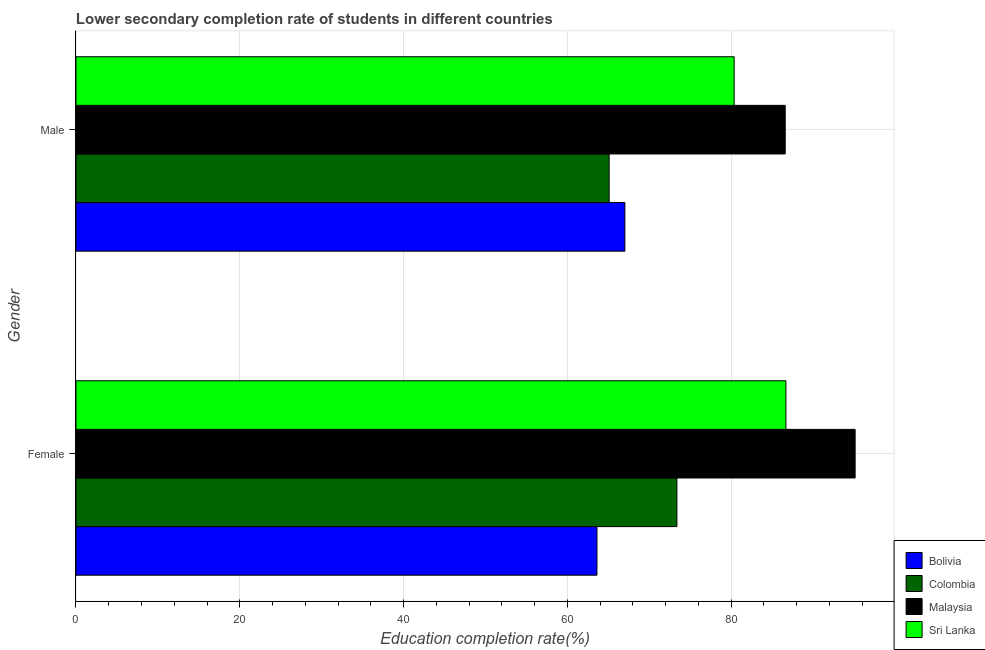How many different coloured bars are there?
Keep it short and to the point. 4. How many bars are there on the 1st tick from the top?
Keep it short and to the point. 4. How many bars are there on the 1st tick from the bottom?
Your answer should be compact. 4. What is the education completion rate of male students in Malaysia?
Offer a terse response. 86.61. Across all countries, what is the maximum education completion rate of female students?
Keep it short and to the point. 95.14. Across all countries, what is the minimum education completion rate of male students?
Your response must be concise. 65.11. In which country was the education completion rate of female students maximum?
Keep it short and to the point. Malaysia. In which country was the education completion rate of female students minimum?
Provide a short and direct response. Bolivia. What is the total education completion rate of female students in the graph?
Make the answer very short. 318.83. What is the difference between the education completion rate of female students in Sri Lanka and that in Bolivia?
Offer a very short reply. 23.07. What is the difference between the education completion rate of female students in Sri Lanka and the education completion rate of male students in Colombia?
Give a very brief answer. 21.58. What is the average education completion rate of male students per country?
Ensure brevity in your answer.  74.78. What is the difference between the education completion rate of male students and education completion rate of female students in Colombia?
Keep it short and to the point. -8.27. In how many countries, is the education completion rate of male students greater than 40 %?
Offer a terse response. 4. What is the ratio of the education completion rate of male students in Sri Lanka to that in Malaysia?
Your response must be concise. 0.93. In how many countries, is the education completion rate of female students greater than the average education completion rate of female students taken over all countries?
Your answer should be very brief. 2. What does the 2nd bar from the top in Male represents?
Provide a succinct answer. Malaysia. What does the 4th bar from the bottom in Female represents?
Your answer should be very brief. Sri Lanka. How many bars are there?
Give a very brief answer. 8. What is the difference between two consecutive major ticks on the X-axis?
Provide a succinct answer. 20. Does the graph contain any zero values?
Provide a succinct answer. No. Does the graph contain grids?
Your response must be concise. Yes. Where does the legend appear in the graph?
Keep it short and to the point. Bottom right. How many legend labels are there?
Your answer should be compact. 4. How are the legend labels stacked?
Give a very brief answer. Vertical. What is the title of the graph?
Your answer should be compact. Lower secondary completion rate of students in different countries. What is the label or title of the X-axis?
Keep it short and to the point. Education completion rate(%). What is the label or title of the Y-axis?
Offer a very short reply. Gender. What is the Education completion rate(%) of Bolivia in Female?
Your answer should be very brief. 63.62. What is the Education completion rate(%) of Colombia in Female?
Your response must be concise. 73.38. What is the Education completion rate(%) of Malaysia in Female?
Ensure brevity in your answer.  95.14. What is the Education completion rate(%) in Sri Lanka in Female?
Offer a terse response. 86.69. What is the Education completion rate(%) of Bolivia in Male?
Offer a very short reply. 67.03. What is the Education completion rate(%) in Colombia in Male?
Give a very brief answer. 65.11. What is the Education completion rate(%) of Malaysia in Male?
Keep it short and to the point. 86.61. What is the Education completion rate(%) of Sri Lanka in Male?
Offer a very short reply. 80.37. Across all Gender, what is the maximum Education completion rate(%) of Bolivia?
Your response must be concise. 67.03. Across all Gender, what is the maximum Education completion rate(%) in Colombia?
Keep it short and to the point. 73.38. Across all Gender, what is the maximum Education completion rate(%) of Malaysia?
Keep it short and to the point. 95.14. Across all Gender, what is the maximum Education completion rate(%) in Sri Lanka?
Provide a succinct answer. 86.69. Across all Gender, what is the minimum Education completion rate(%) in Bolivia?
Offer a very short reply. 63.62. Across all Gender, what is the minimum Education completion rate(%) in Colombia?
Offer a terse response. 65.11. Across all Gender, what is the minimum Education completion rate(%) in Malaysia?
Ensure brevity in your answer.  86.61. Across all Gender, what is the minimum Education completion rate(%) of Sri Lanka?
Make the answer very short. 80.37. What is the total Education completion rate(%) in Bolivia in the graph?
Provide a short and direct response. 130.64. What is the total Education completion rate(%) of Colombia in the graph?
Make the answer very short. 138.48. What is the total Education completion rate(%) in Malaysia in the graph?
Offer a very short reply. 181.75. What is the total Education completion rate(%) in Sri Lanka in the graph?
Provide a succinct answer. 167.06. What is the difference between the Education completion rate(%) of Bolivia in Female and that in Male?
Ensure brevity in your answer.  -3.41. What is the difference between the Education completion rate(%) of Colombia in Female and that in Male?
Make the answer very short. 8.27. What is the difference between the Education completion rate(%) in Malaysia in Female and that in Male?
Your response must be concise. 8.53. What is the difference between the Education completion rate(%) of Sri Lanka in Female and that in Male?
Keep it short and to the point. 6.32. What is the difference between the Education completion rate(%) in Bolivia in Female and the Education completion rate(%) in Colombia in Male?
Your answer should be very brief. -1.49. What is the difference between the Education completion rate(%) in Bolivia in Female and the Education completion rate(%) in Malaysia in Male?
Provide a succinct answer. -22.99. What is the difference between the Education completion rate(%) of Bolivia in Female and the Education completion rate(%) of Sri Lanka in Male?
Offer a very short reply. -16.75. What is the difference between the Education completion rate(%) of Colombia in Female and the Education completion rate(%) of Malaysia in Male?
Your response must be concise. -13.23. What is the difference between the Education completion rate(%) in Colombia in Female and the Education completion rate(%) in Sri Lanka in Male?
Give a very brief answer. -6.99. What is the difference between the Education completion rate(%) of Malaysia in Female and the Education completion rate(%) of Sri Lanka in Male?
Offer a terse response. 14.77. What is the average Education completion rate(%) of Bolivia per Gender?
Ensure brevity in your answer.  65.32. What is the average Education completion rate(%) in Colombia per Gender?
Provide a short and direct response. 69.24. What is the average Education completion rate(%) in Malaysia per Gender?
Keep it short and to the point. 90.87. What is the average Education completion rate(%) in Sri Lanka per Gender?
Your answer should be compact. 83.53. What is the difference between the Education completion rate(%) in Bolivia and Education completion rate(%) in Colombia in Female?
Give a very brief answer. -9.76. What is the difference between the Education completion rate(%) in Bolivia and Education completion rate(%) in Malaysia in Female?
Ensure brevity in your answer.  -31.52. What is the difference between the Education completion rate(%) in Bolivia and Education completion rate(%) in Sri Lanka in Female?
Give a very brief answer. -23.07. What is the difference between the Education completion rate(%) in Colombia and Education completion rate(%) in Malaysia in Female?
Your response must be concise. -21.76. What is the difference between the Education completion rate(%) of Colombia and Education completion rate(%) of Sri Lanka in Female?
Provide a short and direct response. -13.31. What is the difference between the Education completion rate(%) in Malaysia and Education completion rate(%) in Sri Lanka in Female?
Offer a very short reply. 8.45. What is the difference between the Education completion rate(%) in Bolivia and Education completion rate(%) in Colombia in Male?
Your response must be concise. 1.92. What is the difference between the Education completion rate(%) of Bolivia and Education completion rate(%) of Malaysia in Male?
Your answer should be very brief. -19.58. What is the difference between the Education completion rate(%) in Bolivia and Education completion rate(%) in Sri Lanka in Male?
Offer a very short reply. -13.34. What is the difference between the Education completion rate(%) in Colombia and Education completion rate(%) in Malaysia in Male?
Your response must be concise. -21.5. What is the difference between the Education completion rate(%) of Colombia and Education completion rate(%) of Sri Lanka in Male?
Offer a very short reply. -15.26. What is the difference between the Education completion rate(%) in Malaysia and Education completion rate(%) in Sri Lanka in Male?
Provide a succinct answer. 6.24. What is the ratio of the Education completion rate(%) in Bolivia in Female to that in Male?
Keep it short and to the point. 0.95. What is the ratio of the Education completion rate(%) of Colombia in Female to that in Male?
Provide a succinct answer. 1.13. What is the ratio of the Education completion rate(%) in Malaysia in Female to that in Male?
Keep it short and to the point. 1.1. What is the ratio of the Education completion rate(%) in Sri Lanka in Female to that in Male?
Your answer should be very brief. 1.08. What is the difference between the highest and the second highest Education completion rate(%) of Bolivia?
Make the answer very short. 3.41. What is the difference between the highest and the second highest Education completion rate(%) in Colombia?
Ensure brevity in your answer.  8.27. What is the difference between the highest and the second highest Education completion rate(%) of Malaysia?
Provide a succinct answer. 8.53. What is the difference between the highest and the second highest Education completion rate(%) of Sri Lanka?
Provide a succinct answer. 6.32. What is the difference between the highest and the lowest Education completion rate(%) in Bolivia?
Provide a short and direct response. 3.41. What is the difference between the highest and the lowest Education completion rate(%) in Colombia?
Keep it short and to the point. 8.27. What is the difference between the highest and the lowest Education completion rate(%) in Malaysia?
Ensure brevity in your answer.  8.53. What is the difference between the highest and the lowest Education completion rate(%) in Sri Lanka?
Provide a short and direct response. 6.32. 